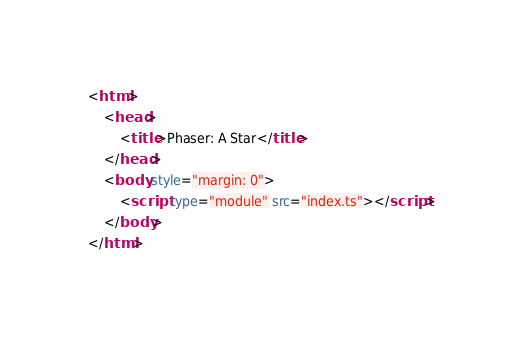<code> <loc_0><loc_0><loc_500><loc_500><_HTML_><html>
	<head>
		<title>Phaser: A Star</title>
	</head>
	<body style="margin: 0">
		<script type="module" src="index.ts"></script>
	</body>
</html>
</code> 